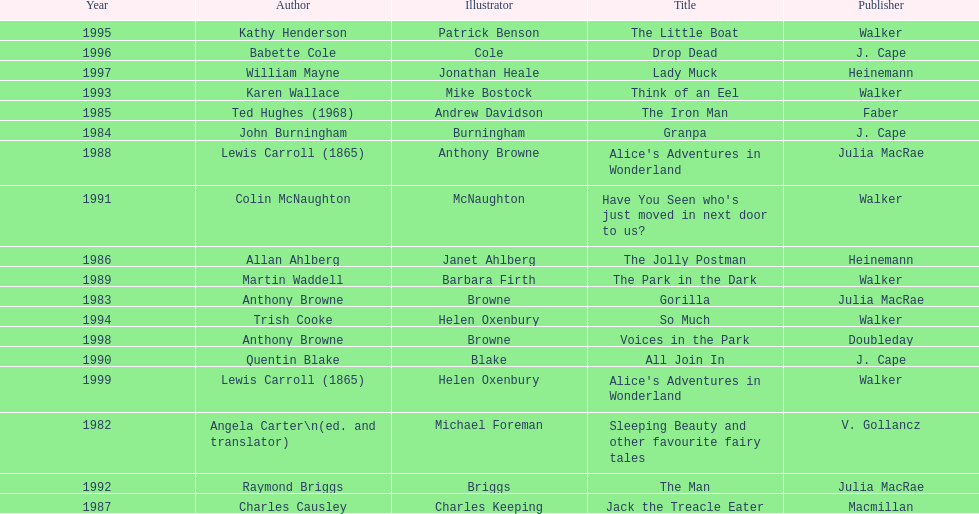Which book won the award a total of 2 times? Alice's Adventures in Wonderland. 